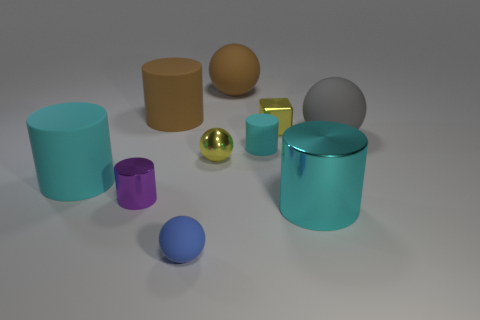What is the purpose of the arrangement of these objects? The purpose of the arrangement seems to be for a visual study. It could be an exploration of forms, textures, and colors in a controlled environment, possibly for an artistic composition or a 3D modeling project. 